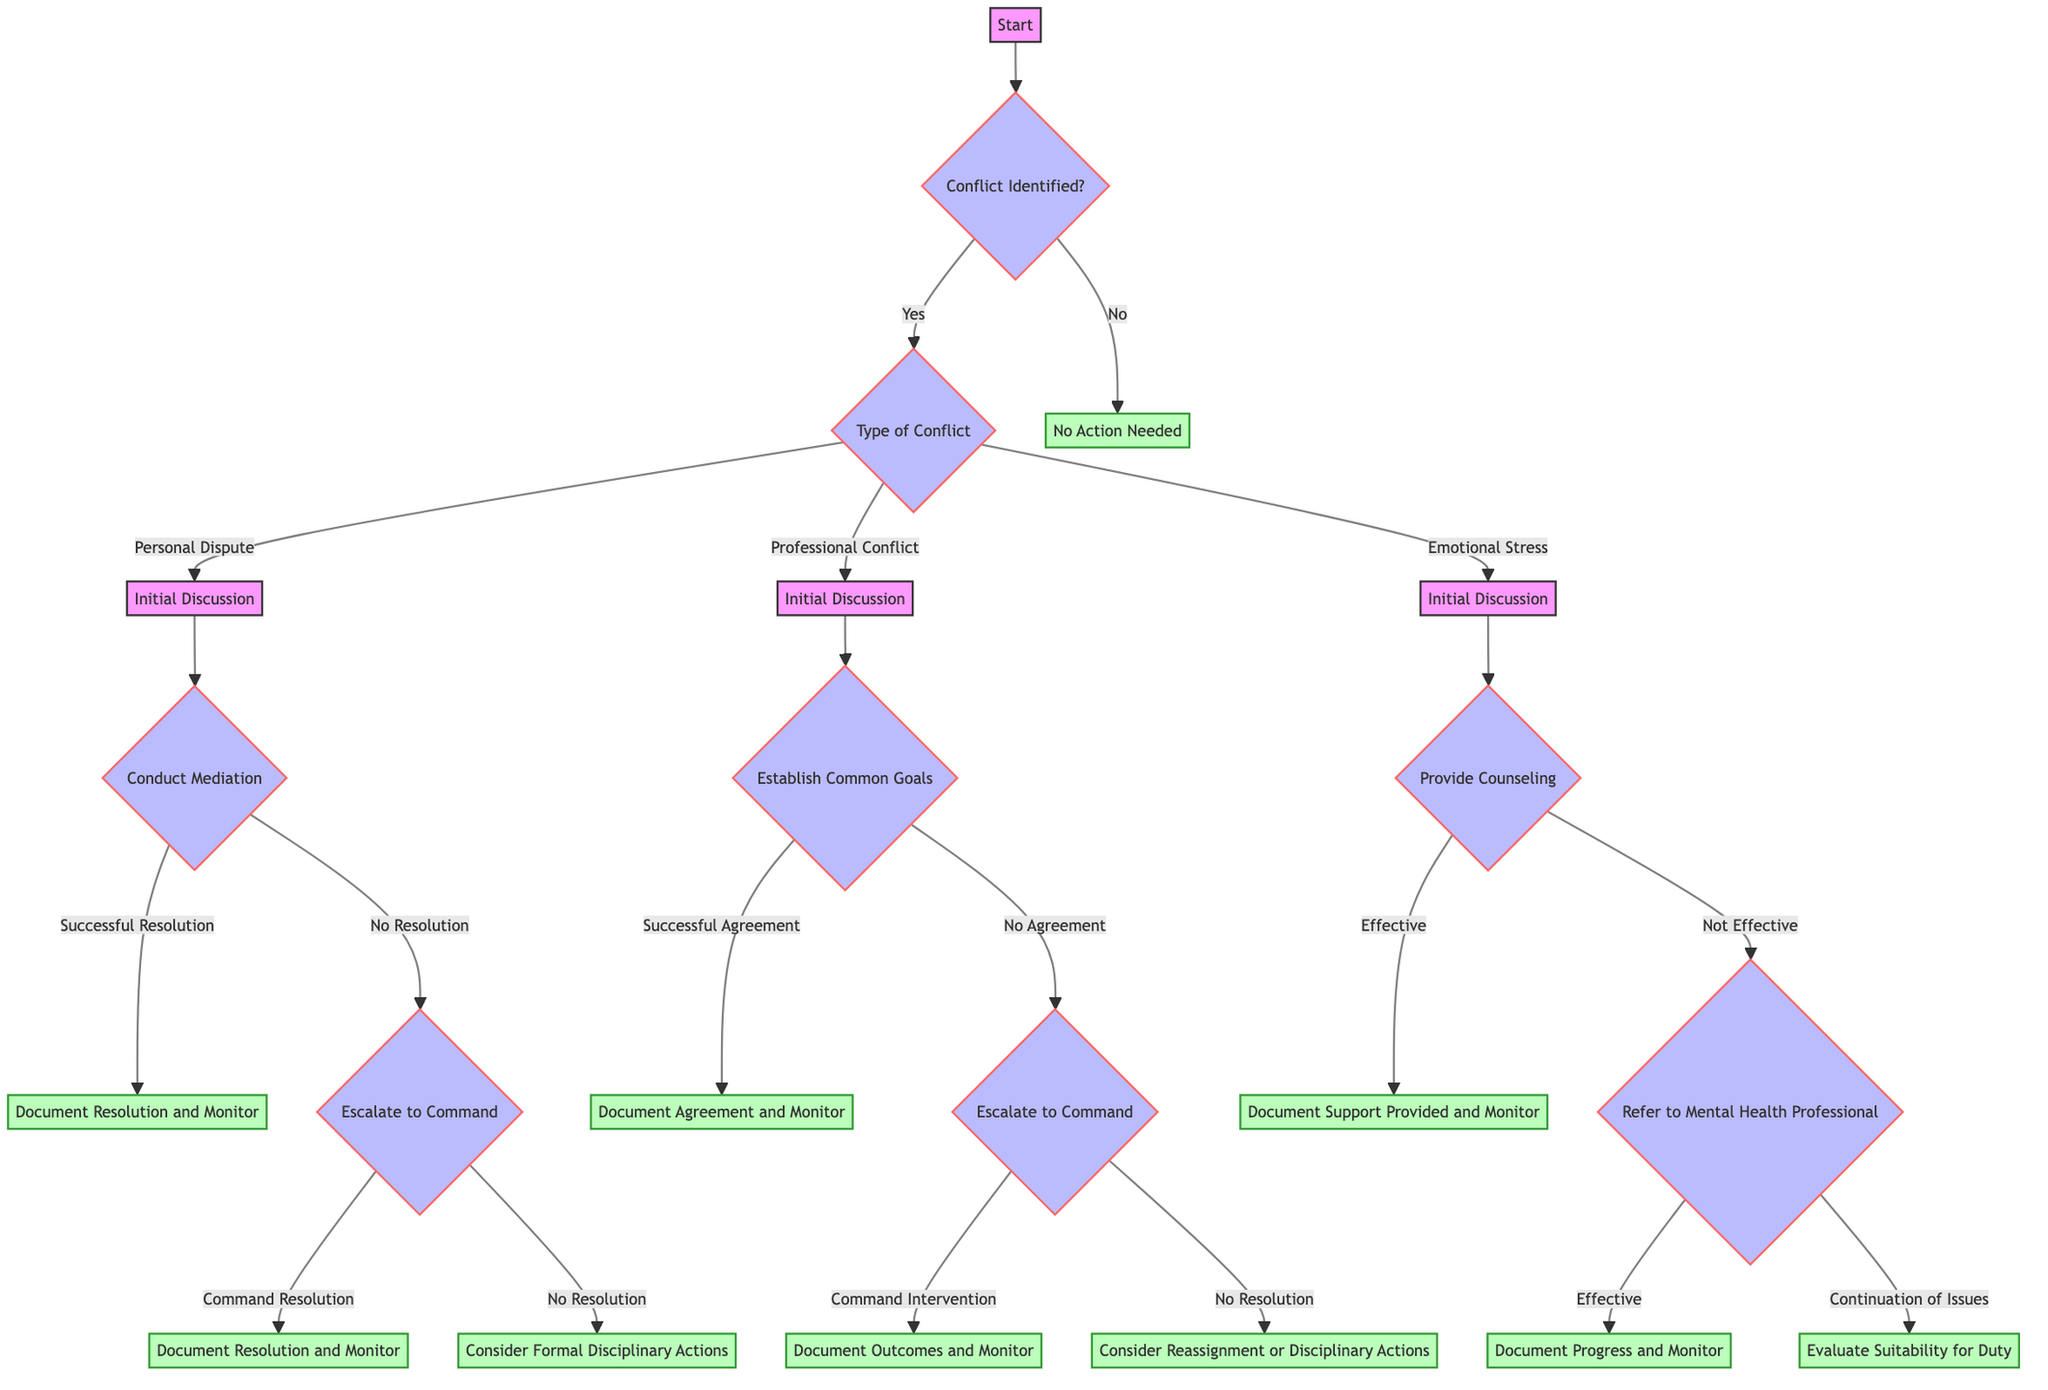What happens if no conflict is identified? The diagram shows that if the answer to "Conflict Identified?" is "No," then the process directs to "No Action Needed" without any further steps.
Answer: No Action Needed What are the branches stemming from "Personal Dispute"? From "Personal Dispute," the next step leads to "Initial Discussion," followed by "Conduct Mediation," which has two outcomes: "Successful Resolution" and "No Resolution."
Answer: Initial Discussion, Conduct Mediation What is the next step if "Establish Common Goals" results in "No Agreement"? If "Establish Common Goals" does not reach an agreement, the next step is "Escalate to Command," leading to further options of "Command Intervention" or "No Resolution."
Answer: Escalate to Command How many types of conflicts are categorized in the decision tree? The decision tree categorizes conflicts into three types: "Personal Dispute," "Professional Conflict," and "Emotional Stress," indicating there are three distinct categories.
Answer: Three What are the two possible outcomes after "Refer to Mental Health Professional"? After "Refer to Mental Health Professional," the two outcomes are either "Effective," leading to "Document Progress and Monitor," or "Continuation of Issues," leading to "Evaluate Suitability for Duty."
Answer: Effective, Continuation of Issues What is the action taken after a "Successful Resolution" in mediation? Following a "Successful Resolution" in mediation, the action specified is to "Document Resolution and Monitor" to ensure that the resolution is maintained and any ongoing issues are tracked.
Answer: Document Resolution and Monitor If "Successful Agreement" is reached, what should be done next? Upon reaching a "Successful Agreement," the diagram indicates that you should "Document Agreement and Monitor" to keep a record of the agreement and track its adherence.
Answer: Document Agreement and Monitor What happens after "Consider Reassignment or Disciplinary Actions"? The decision tree indicates that "Consider Reassignment or Disciplinary Actions" represents a termination point and does not lead to any further actions; it's an endpoint of the decision path.
Answer: Endpoint 